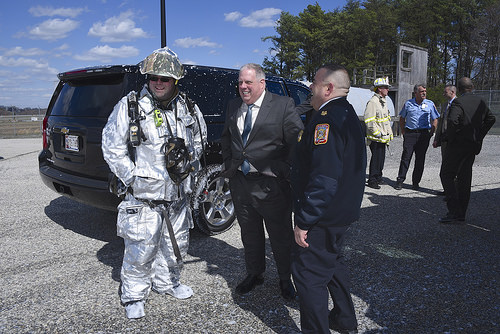<image>
Can you confirm if the astronaut is under the car? No. The astronaut is not positioned under the car. The vertical relationship between these objects is different. Is there a man in front of the car? Yes. The man is positioned in front of the car, appearing closer to the camera viewpoint. 